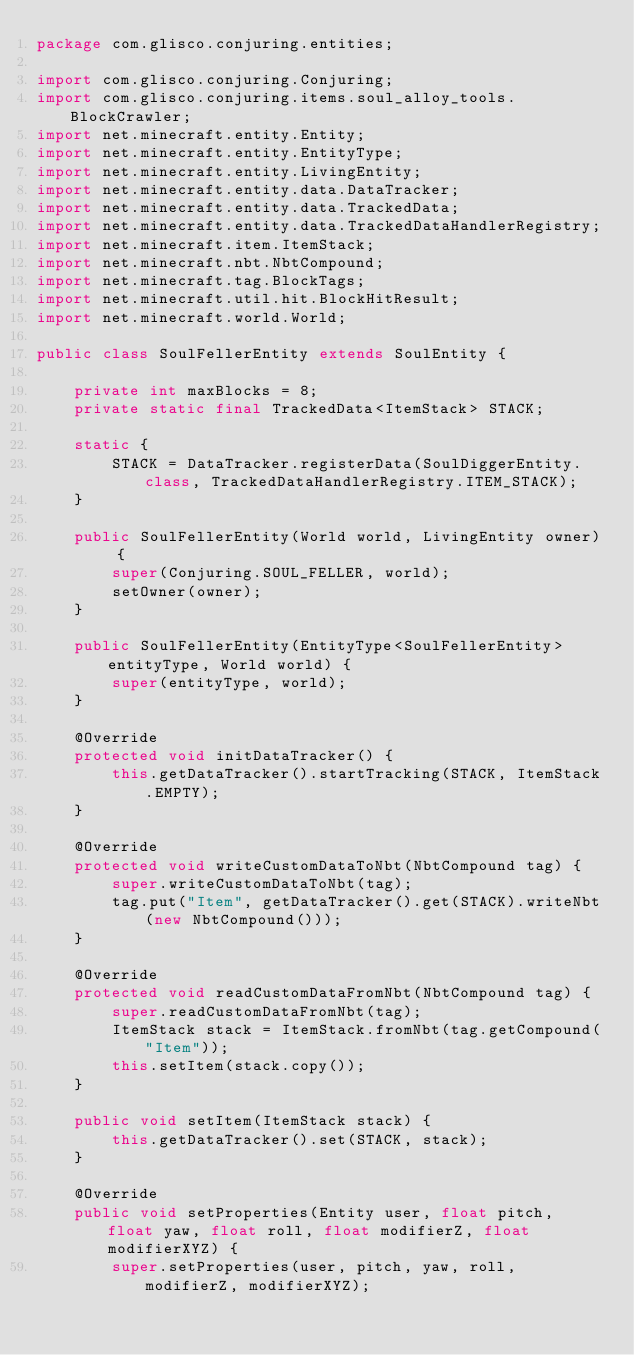<code> <loc_0><loc_0><loc_500><loc_500><_Java_>package com.glisco.conjuring.entities;

import com.glisco.conjuring.Conjuring;
import com.glisco.conjuring.items.soul_alloy_tools.BlockCrawler;
import net.minecraft.entity.Entity;
import net.minecraft.entity.EntityType;
import net.minecraft.entity.LivingEntity;
import net.minecraft.entity.data.DataTracker;
import net.minecraft.entity.data.TrackedData;
import net.minecraft.entity.data.TrackedDataHandlerRegistry;
import net.minecraft.item.ItemStack;
import net.minecraft.nbt.NbtCompound;
import net.minecraft.tag.BlockTags;
import net.minecraft.util.hit.BlockHitResult;
import net.minecraft.world.World;

public class SoulFellerEntity extends SoulEntity {

    private int maxBlocks = 8;
    private static final TrackedData<ItemStack> STACK;

    static {
        STACK = DataTracker.registerData(SoulDiggerEntity.class, TrackedDataHandlerRegistry.ITEM_STACK);
    }

    public SoulFellerEntity(World world, LivingEntity owner) {
        super(Conjuring.SOUL_FELLER, world);
        setOwner(owner);
    }

    public SoulFellerEntity(EntityType<SoulFellerEntity> entityType, World world) {
        super(entityType, world);
    }

    @Override
    protected void initDataTracker() {
        this.getDataTracker().startTracking(STACK, ItemStack.EMPTY);
    }

    @Override
    protected void writeCustomDataToNbt(NbtCompound tag) {
        super.writeCustomDataToNbt(tag);
        tag.put("Item", getDataTracker().get(STACK).writeNbt(new NbtCompound()));
    }

    @Override
    protected void readCustomDataFromNbt(NbtCompound tag) {
        super.readCustomDataFromNbt(tag);
        ItemStack stack = ItemStack.fromNbt(tag.getCompound("Item"));
        this.setItem(stack.copy());
    }

    public void setItem(ItemStack stack) {
        this.getDataTracker().set(STACK, stack);
    }

    @Override
    public void setProperties(Entity user, float pitch, float yaw, float roll, float modifierZ, float modifierXYZ) {
        super.setProperties(user, pitch, yaw, roll, modifierZ, modifierXYZ);</code> 